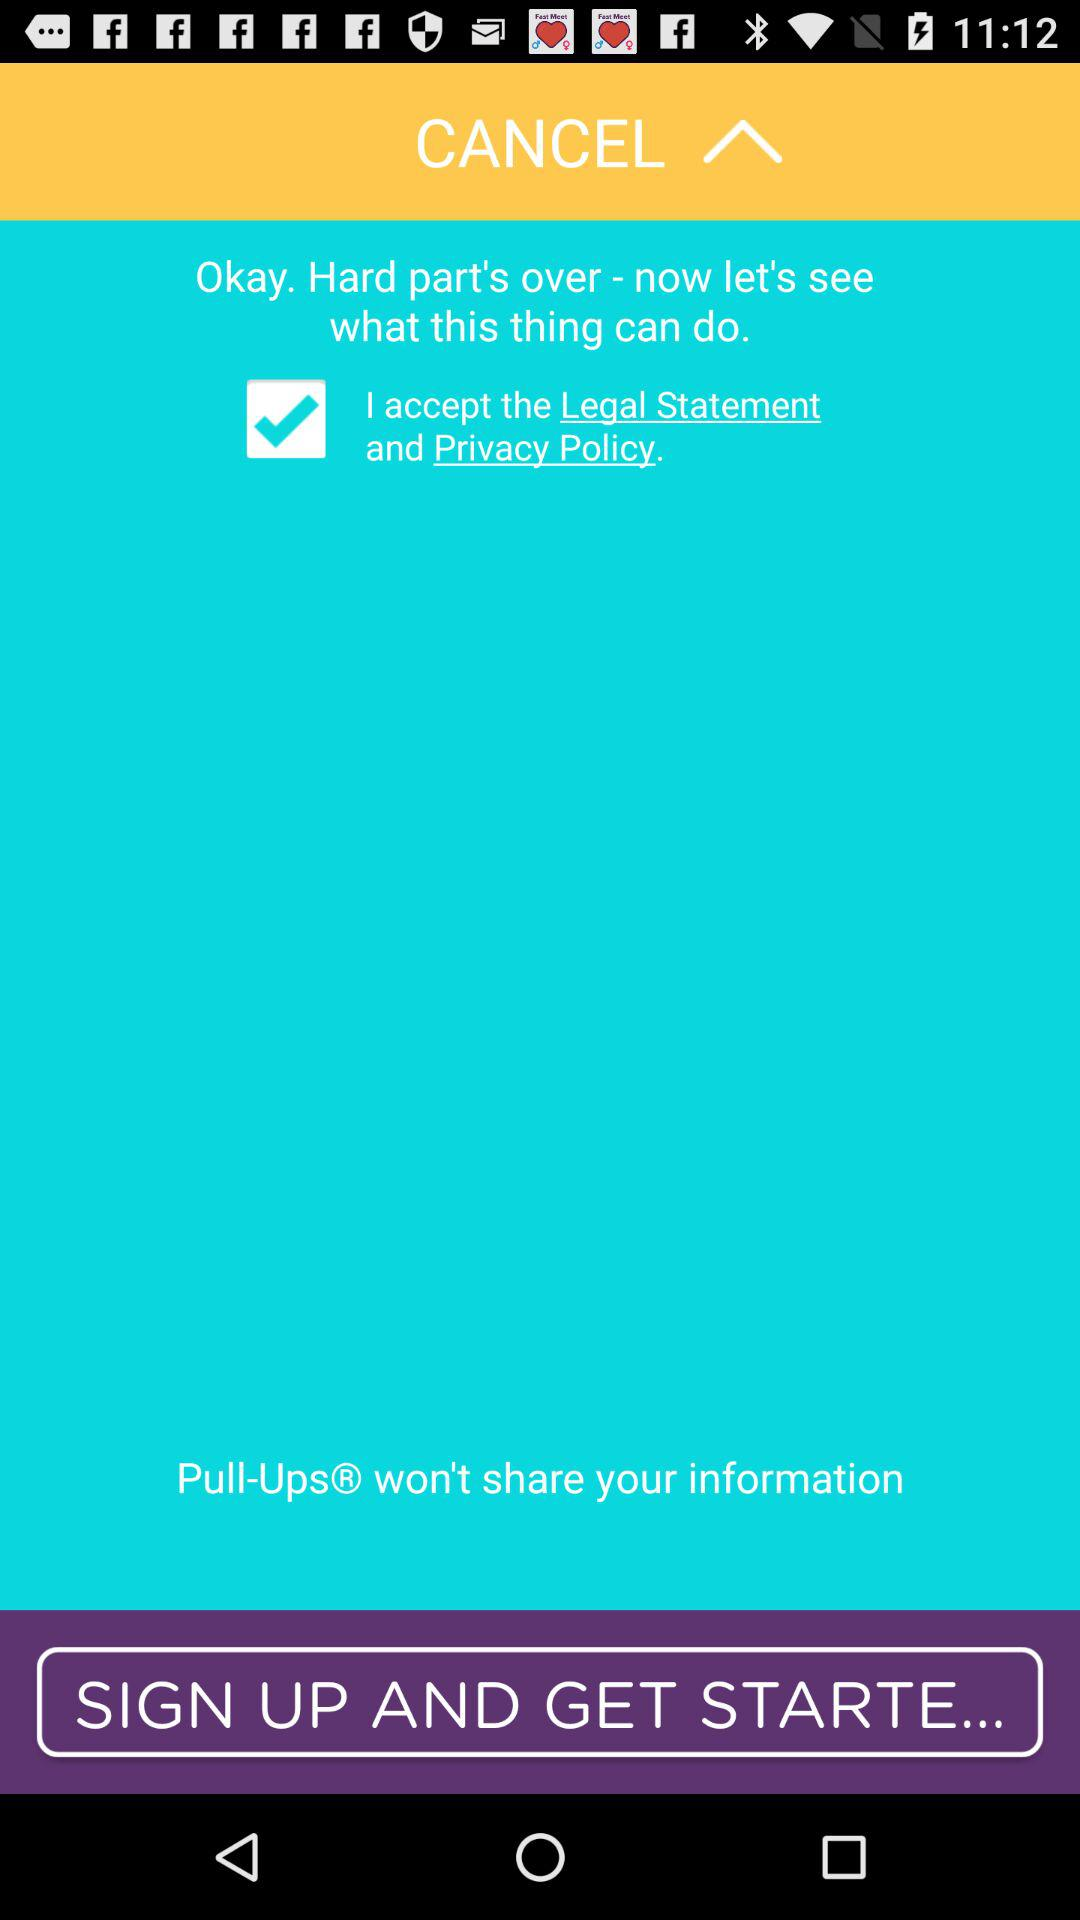What is the status of the option that includes acceptance to the “Legal Statement” and "Privacy Policy"? The status of the option that includes acceptance to the "Legal Statement" and "Privacy Policy" is "on". 